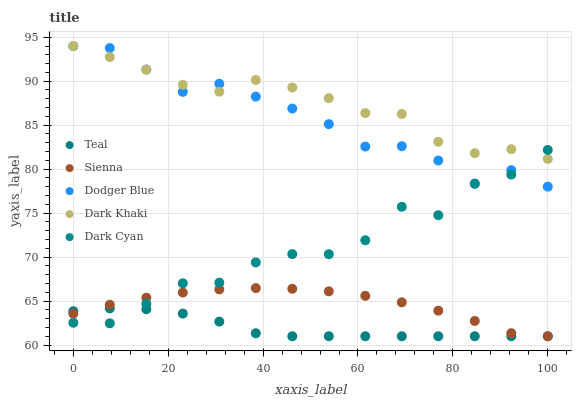Does Teal have the minimum area under the curve?
Answer yes or no. Yes. Does Dark Khaki have the maximum area under the curve?
Answer yes or no. Yes. Does Dodger Blue have the minimum area under the curve?
Answer yes or no. No. Does Dodger Blue have the maximum area under the curve?
Answer yes or no. No. Is Teal the smoothest?
Answer yes or no. Yes. Is Dark Cyan the roughest?
Answer yes or no. Yes. Is Dark Khaki the smoothest?
Answer yes or no. No. Is Dark Khaki the roughest?
Answer yes or no. No. Does Sienna have the lowest value?
Answer yes or no. Yes. Does Dodger Blue have the lowest value?
Answer yes or no. No. Does Dark Khaki have the highest value?
Answer yes or no. Yes. Does Dodger Blue have the highest value?
Answer yes or no. No. Is Sienna less than Dodger Blue?
Answer yes or no. Yes. Is Dodger Blue greater than Sienna?
Answer yes or no. Yes. Does Dodger Blue intersect Dark Cyan?
Answer yes or no. Yes. Is Dodger Blue less than Dark Cyan?
Answer yes or no. No. Is Dodger Blue greater than Dark Cyan?
Answer yes or no. No. Does Sienna intersect Dodger Blue?
Answer yes or no. No. 